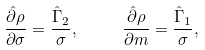Convert formula to latex. <formula><loc_0><loc_0><loc_500><loc_500>\frac { \hat { \partial } \rho } { \partial \sigma } = \frac { \hat { \Gamma } _ { 2 } } { \sigma } , \quad \ \frac { \hat { \partial } \rho } { \partial m } = \frac { \hat { \Gamma } _ { 1 } } { \sigma } ,</formula> 